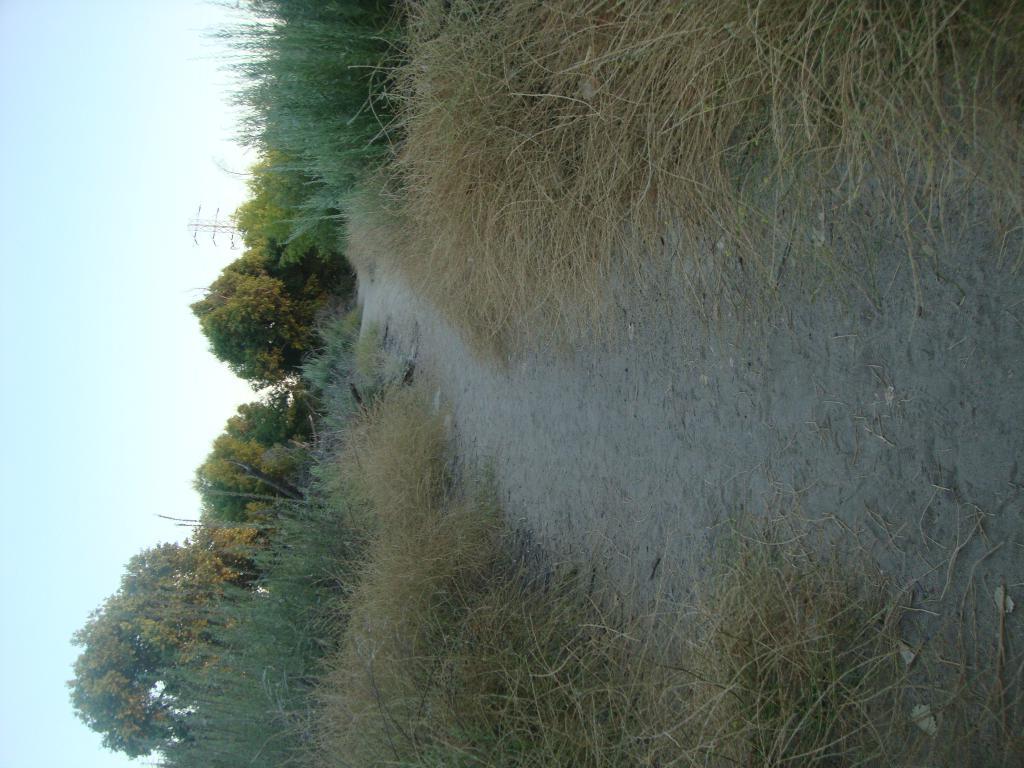Can you describe this image briefly? In this image, we can see a path in between grass. There are some trees in the middle of the image. There is a sky on the left side of the image. 